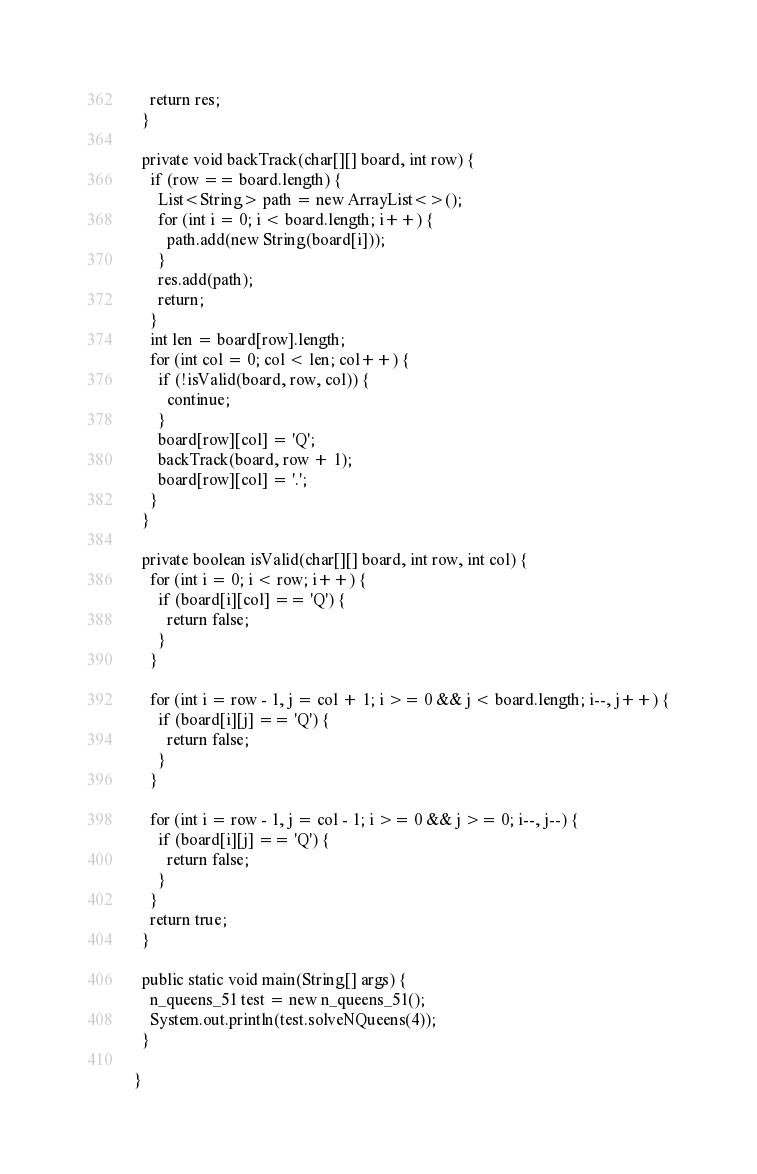<code> <loc_0><loc_0><loc_500><loc_500><_Java_>    return res;
  }

  private void backTrack(char[][] board, int row) {
    if (row == board.length) {
      List<String> path = new ArrayList<>();
      for (int i = 0; i < board.length; i++) {
        path.add(new String(board[i]));
      }
      res.add(path);
      return;
    }
    int len = board[row].length;
    for (int col = 0; col < len; col++) {
      if (!isValid(board, row, col)) {
        continue;
      }
      board[row][col] = 'Q';
      backTrack(board, row + 1);
      board[row][col] = '.';
    }
  }

  private boolean isValid(char[][] board, int row, int col) {
    for (int i = 0; i < row; i++) {
      if (board[i][col] == 'Q') {
        return false;
      }
    }

    for (int i = row - 1, j = col + 1; i >= 0 && j < board.length; i--, j++) {
      if (board[i][j] == 'Q') {
        return false;
      }
    }

    for (int i = row - 1, j = col - 1; i >= 0 && j >= 0; i--, j--) {
      if (board[i][j] == 'Q') {
        return false;
      }
    }
    return true;
  }

  public static void main(String[] args) {
    n_queens_51 test = new n_queens_51();
    System.out.println(test.solveNQueens(4));
  }

}
</code> 